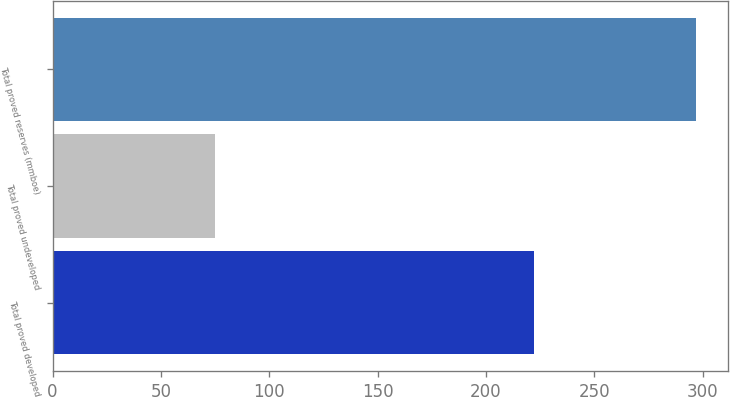Convert chart to OTSL. <chart><loc_0><loc_0><loc_500><loc_500><bar_chart><fcel>Total proved developed<fcel>Total proved undeveloped<fcel>Total proved reserves (mmboe)<nl><fcel>222<fcel>75<fcel>297<nl></chart> 